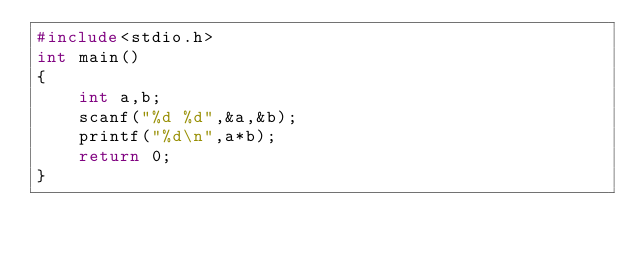<code> <loc_0><loc_0><loc_500><loc_500><_C_>#include<stdio.h>
int main()
{
    int a,b;
    scanf("%d %d",&a,&b);
    printf("%d\n",a*b);
    return 0;
}
</code> 